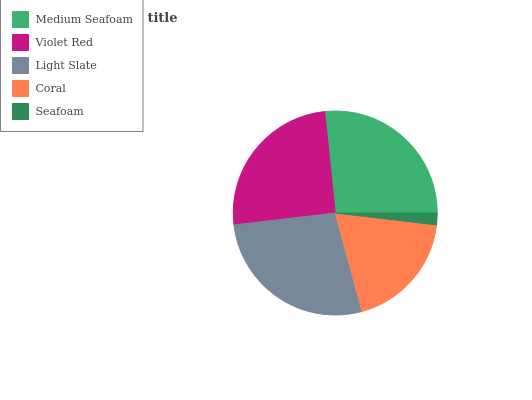Is Seafoam the minimum?
Answer yes or no. Yes. Is Light Slate the maximum?
Answer yes or no. Yes. Is Violet Red the minimum?
Answer yes or no. No. Is Violet Red the maximum?
Answer yes or no. No. Is Medium Seafoam greater than Violet Red?
Answer yes or no. Yes. Is Violet Red less than Medium Seafoam?
Answer yes or no. Yes. Is Violet Red greater than Medium Seafoam?
Answer yes or no. No. Is Medium Seafoam less than Violet Red?
Answer yes or no. No. Is Violet Red the high median?
Answer yes or no. Yes. Is Violet Red the low median?
Answer yes or no. Yes. Is Light Slate the high median?
Answer yes or no. No. Is Medium Seafoam the low median?
Answer yes or no. No. 